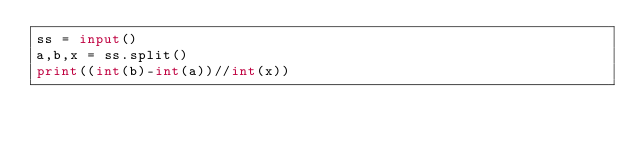Convert code to text. <code><loc_0><loc_0><loc_500><loc_500><_Python_>ss = input()
a,b,x = ss.split()
print((int(b)-int(a))//int(x))</code> 